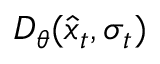Convert formula to latex. <formula><loc_0><loc_0><loc_500><loc_500>D _ { \theta } ( \hat { x } _ { t } , \sigma _ { t } )</formula> 